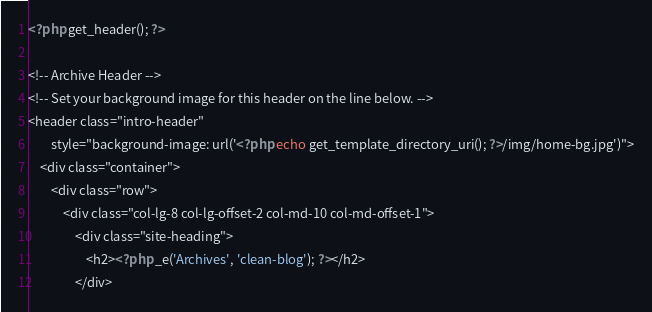<code> <loc_0><loc_0><loc_500><loc_500><_PHP_><?php get_header(); ?>

<!-- Archive Header -->
<!-- Set your background image for this header on the line below. -->
<header class="intro-header"
        style="background-image: url('<?php echo get_template_directory_uri(); ?>/img/home-bg.jpg')">
    <div class="container">
        <div class="row">
            <div class="col-lg-8 col-lg-offset-2 col-md-10 col-md-offset-1">
                <div class="site-heading">
                    <h2><?php _e('Archives', 'clean-blog'); ?></h2>
                </div></code> 